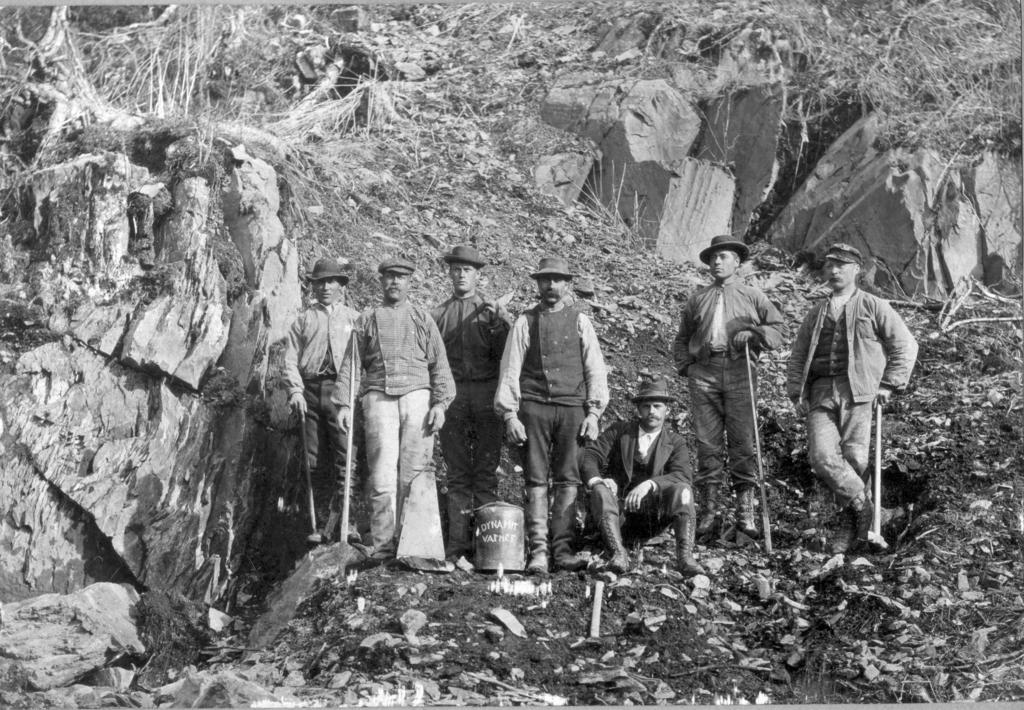What are the people in the image doing? The people in the image are standing and sitting, and they are holding sticks and hammers. What object is in front of the people? There is an object in front of the people, but the specific object is not mentioned in the facts. What type of terrain is visible in the image? There are rocks and grass visible in the image. How many horns can be seen in the image? There are no horns present in the image. Is there a sink visible in the image? There is no sink present in the image. 